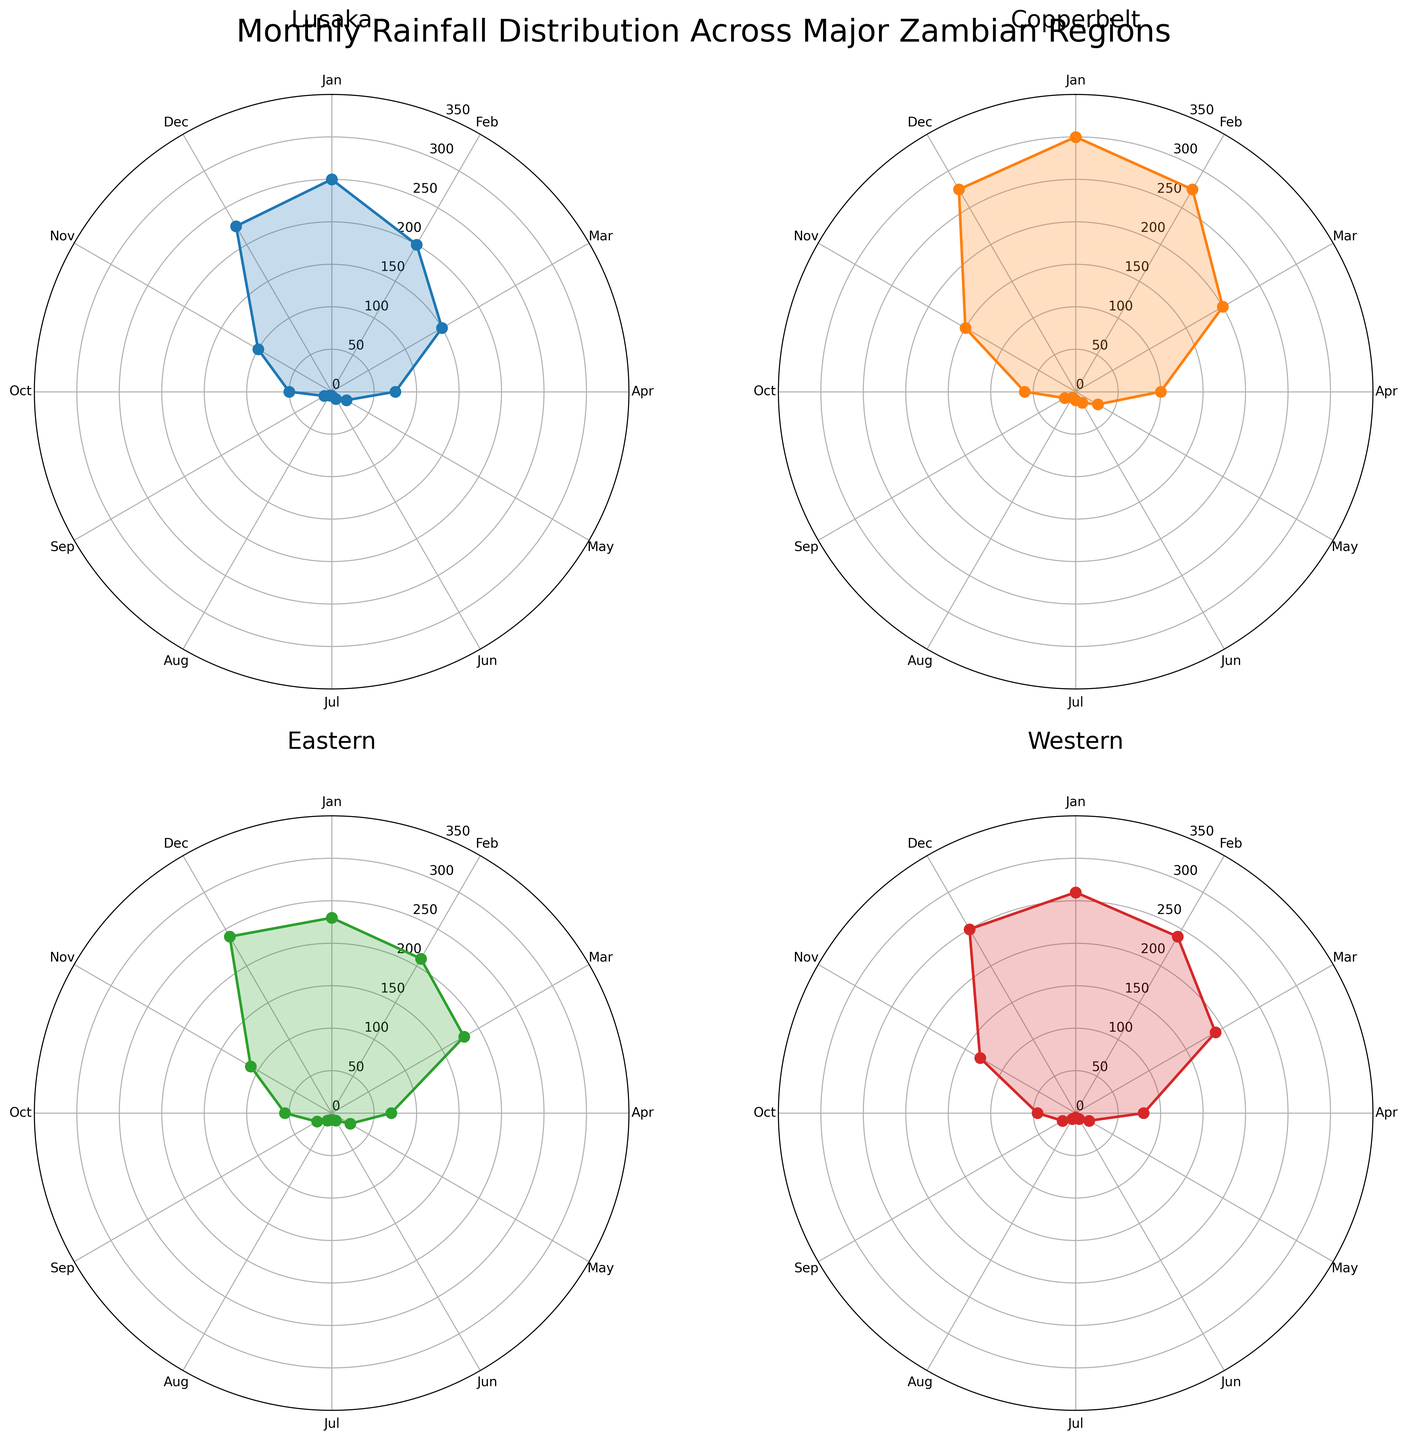What is the title of the figure? The title is usually found at the top of the figure and summarizes the main topic. In this figure, it is stated clearly.
Answer: Monthly Rainfall Distribution Across Major Zambian Regions Which region shows the highest rainfall in January? To find this, look for the point marked "January" (or "Jan") and the corresponding value for each region. The region with the highest point will have the highest rainfall.
Answer: Copperbelt In which month does Lusaka receive the least rainfall, and how much is it? Check the radial values for Lusaka for each month. The smallest value indicates the month with the least rainfall.
Answer: July, 5 mm Between the months of February and March, how much does rainfall decrease in Western region? Locate the values for February and March for Western region and subtract the March value from the February value.
Answer: 50 mm How does the average rainfall in December compare across all four regions? Calculate the average by summing the December rainfall values for all regions and dividing by four. Then, interpret if they are close or if there are significant differences.
Answer: The average is similar, around 247.5 mm Which region has the most consistent rainfall pattern throughout the year? Consistency can be gauged by observing how little the rainfall values vary from month to month. Look for a region where the values are relatively stable.
Answer: Western What is the rainfall difference between the wettest and driest month in Eastern region? Identify the wettest and driest months in the Eastern region and subtract the driest month's value from the wettest month's value.
Answer: 230 mm During which months does Copperbelt region's rainfall exceed 200 mm? Look at the radial values for each month in Copperbelt. Note the months where the values go beyond 200 mm.
Answer: January, February, December 